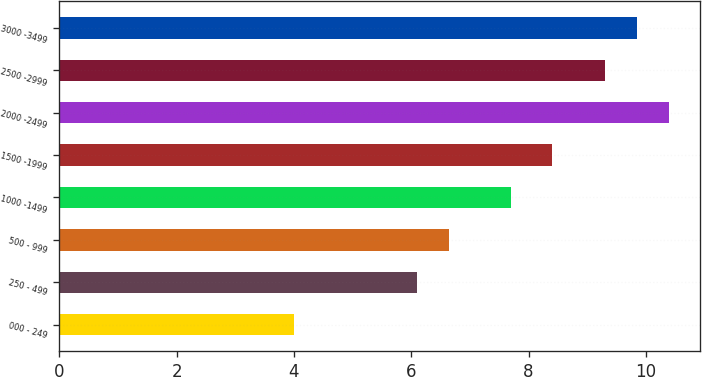Convert chart. <chart><loc_0><loc_0><loc_500><loc_500><bar_chart><fcel>000 - 249<fcel>250 - 499<fcel>500 - 999<fcel>1000 -1499<fcel>1500 -1999<fcel>2000 -2499<fcel>2500 -2999<fcel>3000 -3499<nl><fcel>4<fcel>6.1<fcel>6.65<fcel>7.7<fcel>8.4<fcel>10.4<fcel>9.3<fcel>9.85<nl></chart> 